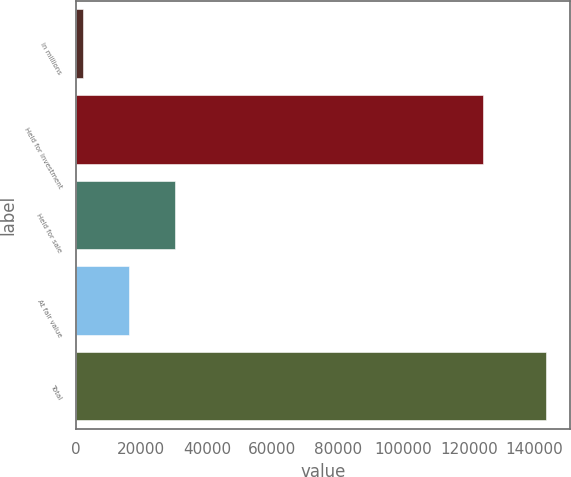<chart> <loc_0><loc_0><loc_500><loc_500><bar_chart><fcel>in millions<fcel>Held for investment<fcel>Held for sale<fcel>At fair value<fcel>Total<nl><fcel>2017<fcel>124504<fcel>30362.8<fcel>16189.9<fcel>143746<nl></chart> 